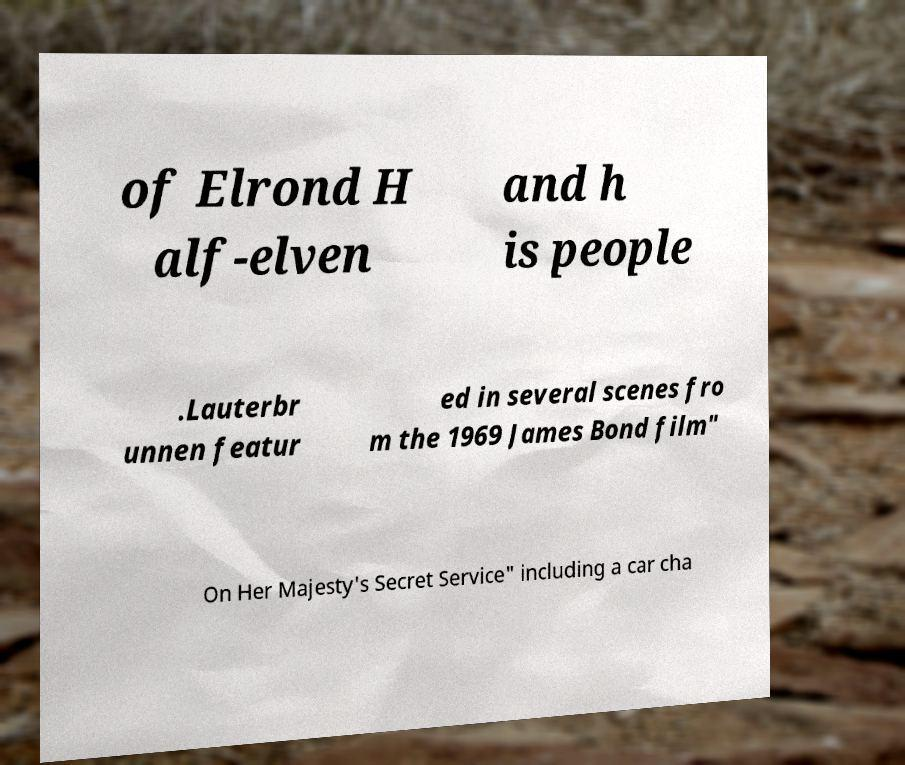Can you accurately transcribe the text from the provided image for me? of Elrond H alf-elven and h is people .Lauterbr unnen featur ed in several scenes fro m the 1969 James Bond film" On Her Majesty's Secret Service" including a car cha 